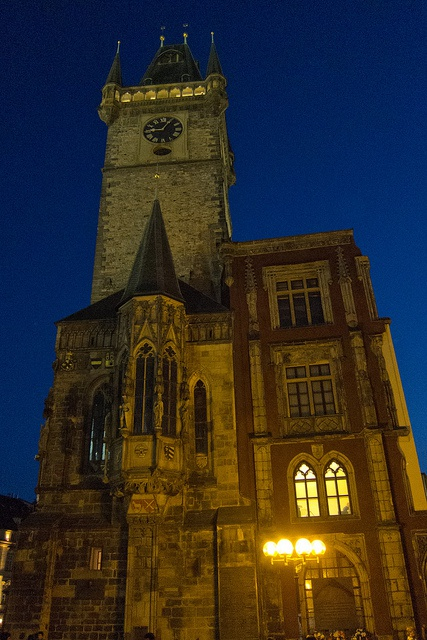Describe the objects in this image and their specific colors. I can see a clock in navy, black, darkgreen, and olive tones in this image. 